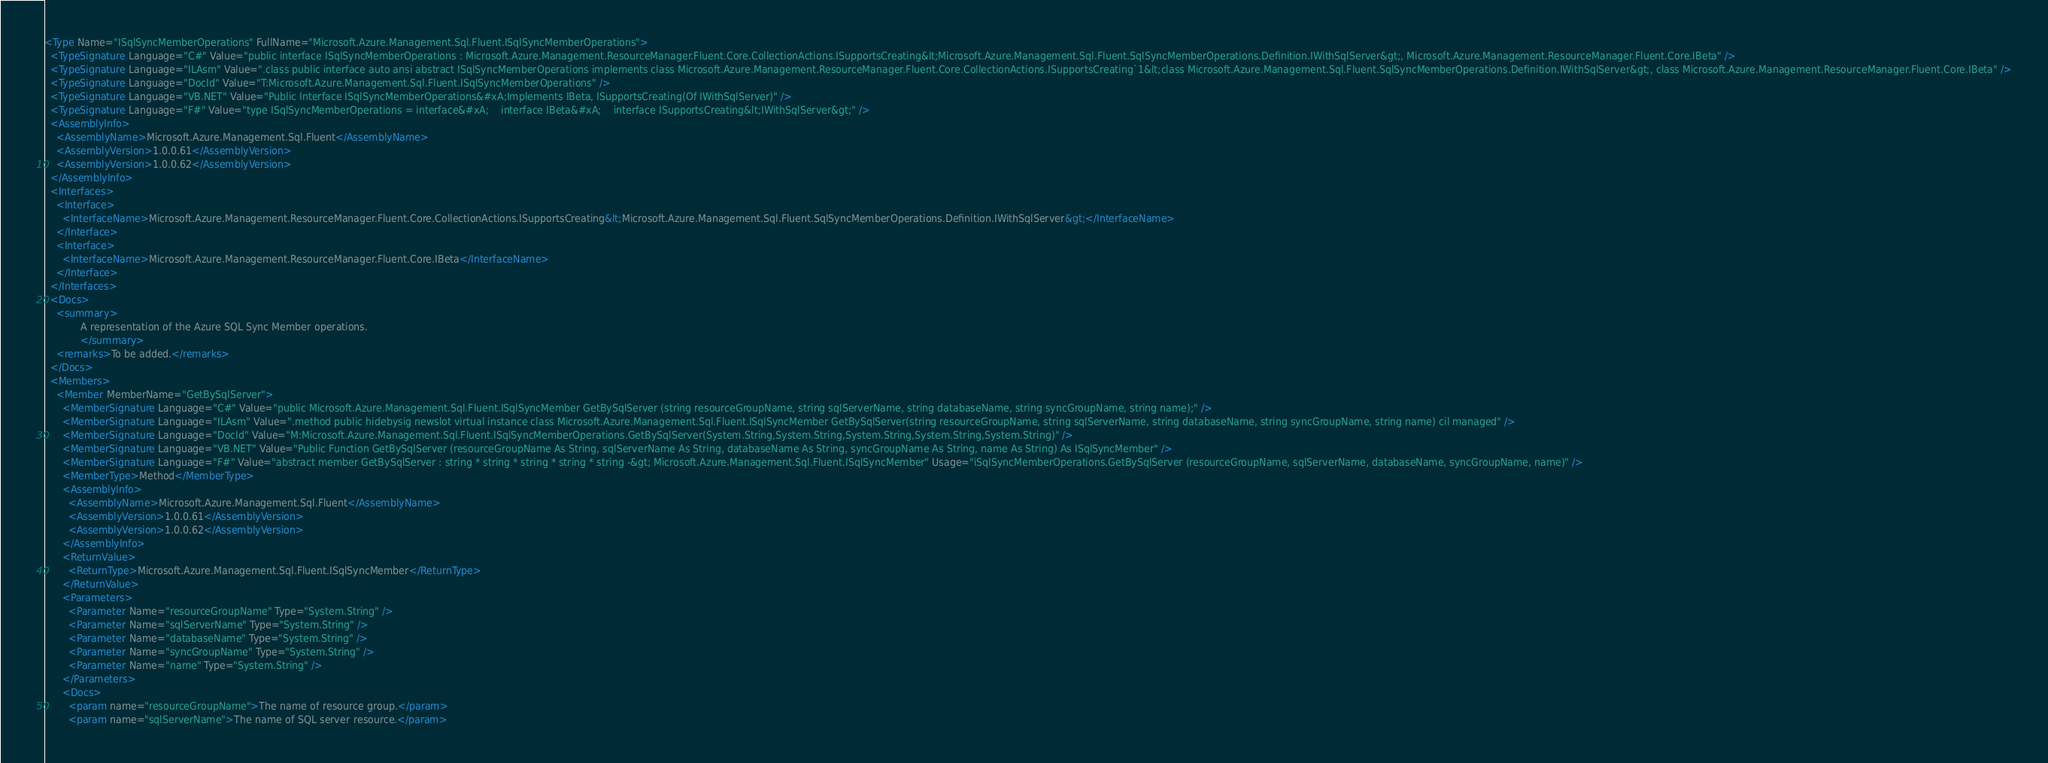Convert code to text. <code><loc_0><loc_0><loc_500><loc_500><_XML_><Type Name="ISqlSyncMemberOperations" FullName="Microsoft.Azure.Management.Sql.Fluent.ISqlSyncMemberOperations">
  <TypeSignature Language="C#" Value="public interface ISqlSyncMemberOperations : Microsoft.Azure.Management.ResourceManager.Fluent.Core.CollectionActions.ISupportsCreating&lt;Microsoft.Azure.Management.Sql.Fluent.SqlSyncMemberOperations.Definition.IWithSqlServer&gt;, Microsoft.Azure.Management.ResourceManager.Fluent.Core.IBeta" />
  <TypeSignature Language="ILAsm" Value=".class public interface auto ansi abstract ISqlSyncMemberOperations implements class Microsoft.Azure.Management.ResourceManager.Fluent.Core.CollectionActions.ISupportsCreating`1&lt;class Microsoft.Azure.Management.Sql.Fluent.SqlSyncMemberOperations.Definition.IWithSqlServer&gt;, class Microsoft.Azure.Management.ResourceManager.Fluent.Core.IBeta" />
  <TypeSignature Language="DocId" Value="T:Microsoft.Azure.Management.Sql.Fluent.ISqlSyncMemberOperations" />
  <TypeSignature Language="VB.NET" Value="Public Interface ISqlSyncMemberOperations&#xA;Implements IBeta, ISupportsCreating(Of IWithSqlServer)" />
  <TypeSignature Language="F#" Value="type ISqlSyncMemberOperations = interface&#xA;    interface IBeta&#xA;    interface ISupportsCreating&lt;IWithSqlServer&gt;" />
  <AssemblyInfo>
    <AssemblyName>Microsoft.Azure.Management.Sql.Fluent</AssemblyName>
    <AssemblyVersion>1.0.0.61</AssemblyVersion>
    <AssemblyVersion>1.0.0.62</AssemblyVersion>
  </AssemblyInfo>
  <Interfaces>
    <Interface>
      <InterfaceName>Microsoft.Azure.Management.ResourceManager.Fluent.Core.CollectionActions.ISupportsCreating&lt;Microsoft.Azure.Management.Sql.Fluent.SqlSyncMemberOperations.Definition.IWithSqlServer&gt;</InterfaceName>
    </Interface>
    <Interface>
      <InterfaceName>Microsoft.Azure.Management.ResourceManager.Fluent.Core.IBeta</InterfaceName>
    </Interface>
  </Interfaces>
  <Docs>
    <summary>
            A representation of the Azure SQL Sync Member operations.
            </summary>
    <remarks>To be added.</remarks>
  </Docs>
  <Members>
    <Member MemberName="GetBySqlServer">
      <MemberSignature Language="C#" Value="public Microsoft.Azure.Management.Sql.Fluent.ISqlSyncMember GetBySqlServer (string resourceGroupName, string sqlServerName, string databaseName, string syncGroupName, string name);" />
      <MemberSignature Language="ILAsm" Value=".method public hidebysig newslot virtual instance class Microsoft.Azure.Management.Sql.Fluent.ISqlSyncMember GetBySqlServer(string resourceGroupName, string sqlServerName, string databaseName, string syncGroupName, string name) cil managed" />
      <MemberSignature Language="DocId" Value="M:Microsoft.Azure.Management.Sql.Fluent.ISqlSyncMemberOperations.GetBySqlServer(System.String,System.String,System.String,System.String,System.String)" />
      <MemberSignature Language="VB.NET" Value="Public Function GetBySqlServer (resourceGroupName As String, sqlServerName As String, databaseName As String, syncGroupName As String, name As String) As ISqlSyncMember" />
      <MemberSignature Language="F#" Value="abstract member GetBySqlServer : string * string * string * string * string -&gt; Microsoft.Azure.Management.Sql.Fluent.ISqlSyncMember" Usage="iSqlSyncMemberOperations.GetBySqlServer (resourceGroupName, sqlServerName, databaseName, syncGroupName, name)" />
      <MemberType>Method</MemberType>
      <AssemblyInfo>
        <AssemblyName>Microsoft.Azure.Management.Sql.Fluent</AssemblyName>
        <AssemblyVersion>1.0.0.61</AssemblyVersion>
        <AssemblyVersion>1.0.0.62</AssemblyVersion>
      </AssemblyInfo>
      <ReturnValue>
        <ReturnType>Microsoft.Azure.Management.Sql.Fluent.ISqlSyncMember</ReturnType>
      </ReturnValue>
      <Parameters>
        <Parameter Name="resourceGroupName" Type="System.String" />
        <Parameter Name="sqlServerName" Type="System.String" />
        <Parameter Name="databaseName" Type="System.String" />
        <Parameter Name="syncGroupName" Type="System.String" />
        <Parameter Name="name" Type="System.String" />
      </Parameters>
      <Docs>
        <param name="resourceGroupName">The name of resource group.</param>
        <param name="sqlServerName">The name of SQL server resource.</param></code> 